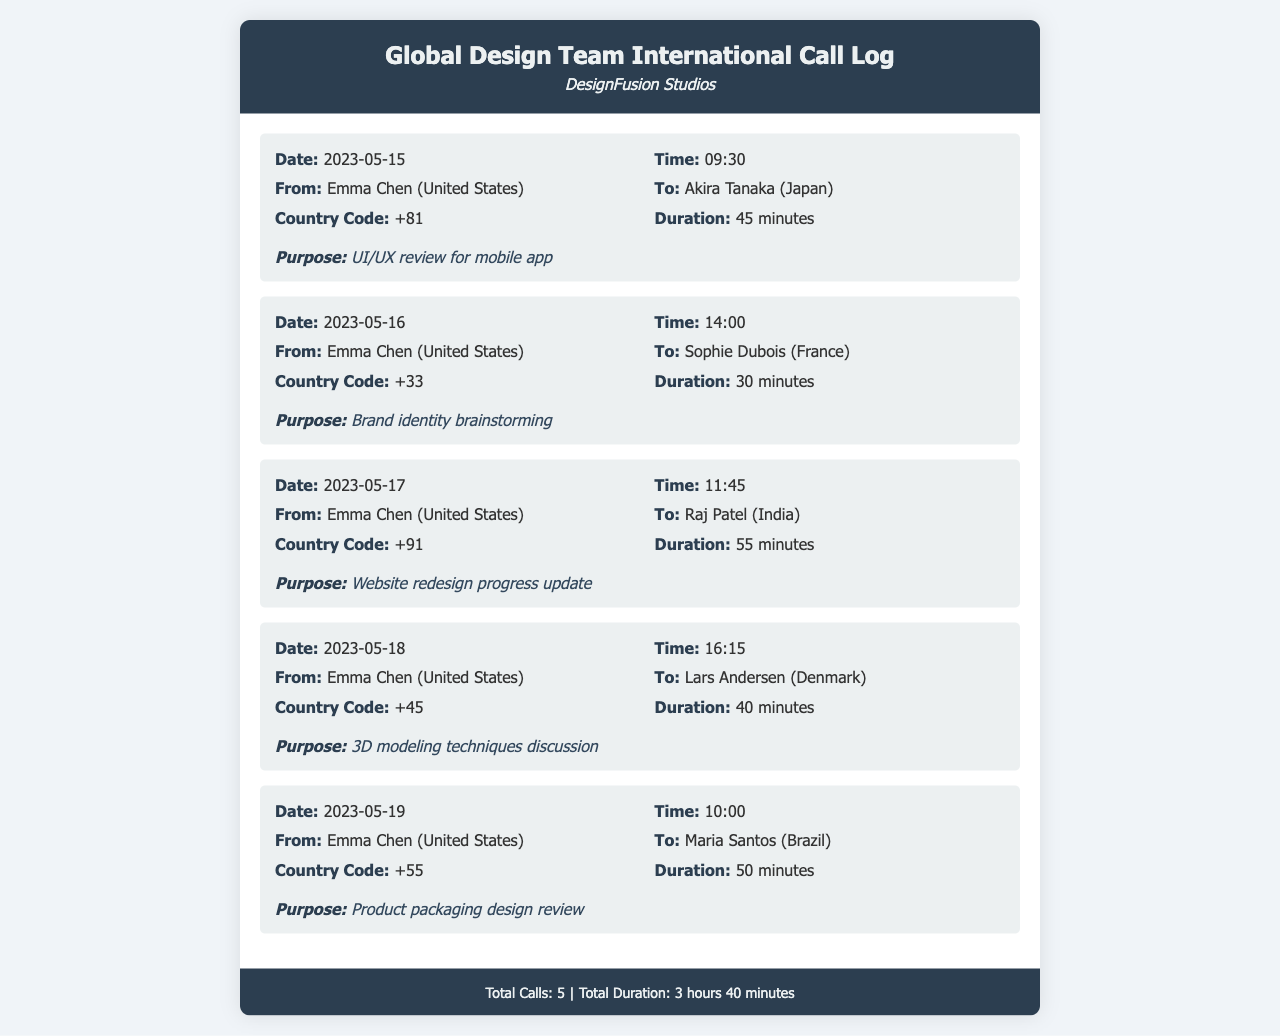What was the duration of the call to Japan? The duration of the call to Japan is provided as 45 minutes in the document.
Answer: 45 minutes Who initiated the call to France? Emma Chen is listed as the caller in the call to France on the 2023-05-16 record.
Answer: Emma Chen What is the country code for India? The country code for India is specified as +91 in the call record.
Answer: +91 How many total calls were made? The footer of the document states that there were a total of 5 calls made.
Answer: 5 What was the purpose of the call to Brazil? The purpose of the call to Brazil is listed as "Product packaging design review" in the document.
Answer: Product packaging design review Which country did the call on May 18th go to? The call on May 18th was made to Lars Andersen in Denmark, as indicated in the call record.
Answer: Denmark How long was the call to India? The call duration to India, recorded on May 17th, is 55 minutes.
Answer: 55 minutes What is the total duration of all calls? The document footer provides the total duration of all calls as 3 hours 40 minutes.
Answer: 3 hours 40 minutes 